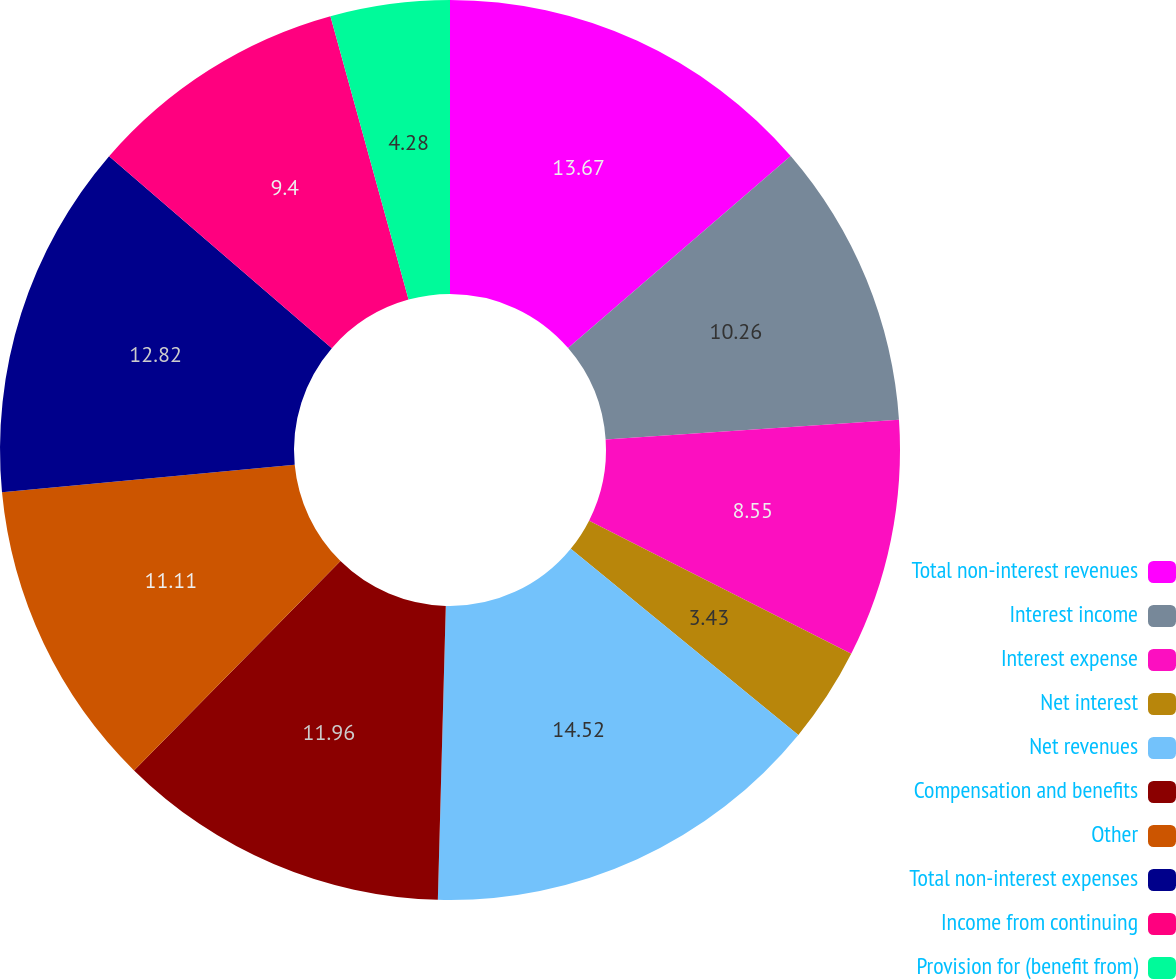<chart> <loc_0><loc_0><loc_500><loc_500><pie_chart><fcel>Total non-interest revenues<fcel>Interest income<fcel>Interest expense<fcel>Net interest<fcel>Net revenues<fcel>Compensation and benefits<fcel>Other<fcel>Total non-interest expenses<fcel>Income from continuing<fcel>Provision for (benefit from)<nl><fcel>13.67%<fcel>10.26%<fcel>8.55%<fcel>3.43%<fcel>14.52%<fcel>11.96%<fcel>11.11%<fcel>12.82%<fcel>9.4%<fcel>4.28%<nl></chart> 